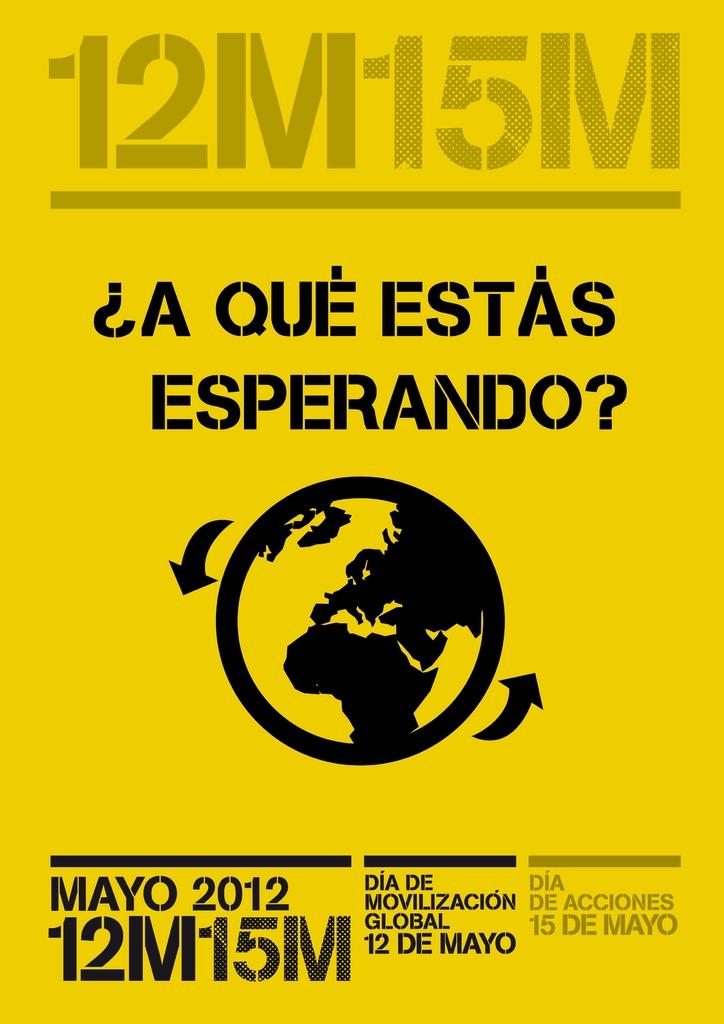What is the month and year on the poster?
Your response must be concise. Mayo 2012. 